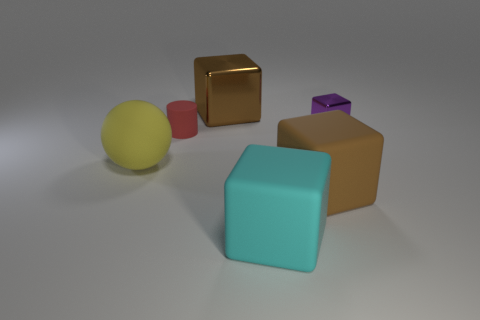Subtract all tiny cubes. How many cubes are left? 3 Subtract all purple blocks. How many blocks are left? 3 Add 3 green shiny things. How many objects exist? 9 Subtract all blocks. How many objects are left? 2 Subtract 1 cubes. How many cubes are left? 3 Subtract all cyan blocks. Subtract all rubber cubes. How many objects are left? 3 Add 1 brown matte cubes. How many brown matte cubes are left? 2 Add 6 yellow things. How many yellow things exist? 7 Subtract 1 yellow spheres. How many objects are left? 5 Subtract all red blocks. Subtract all purple spheres. How many blocks are left? 4 